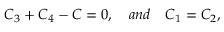Convert formula to latex. <formula><loc_0><loc_0><loc_500><loc_500>C _ { 3 } + C _ { 4 } - C = 0 , \quad a n d \quad C _ { 1 } = C _ { 2 } ,</formula> 